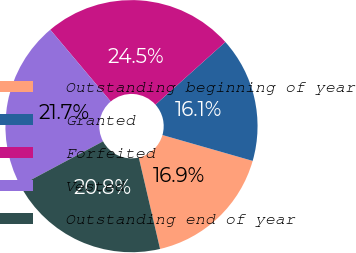Convert chart to OTSL. <chart><loc_0><loc_0><loc_500><loc_500><pie_chart><fcel>Outstanding beginning of year<fcel>Granted<fcel>Forfeited<fcel>Vested<fcel>Outstanding end of year<nl><fcel>16.92%<fcel>16.08%<fcel>24.5%<fcel>21.67%<fcel>20.83%<nl></chart> 